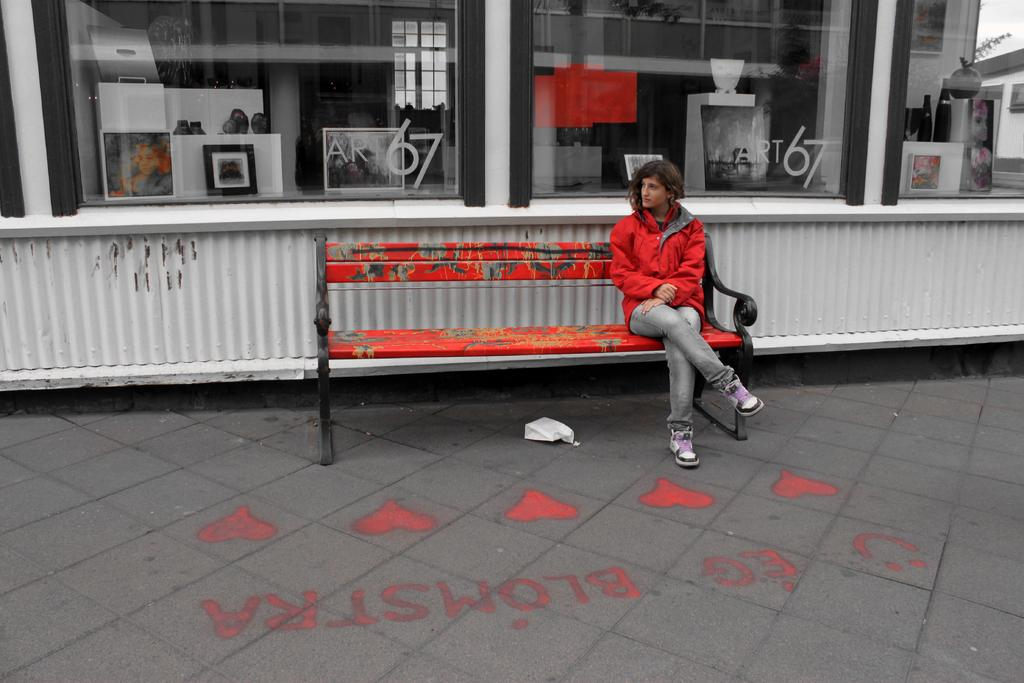Where was the image taken? The image was taken on a street. What can be seen in the center of the image? There is a bench in the center of the image. Who is sitting on the bench? A lady is sitting on the bench. What can be seen in the background of the image? There is a building in the background of the image. What type of voice can be heard coming from the lady's toes in the image? There is no indication in the image that the lady's toes are producing any voice, as the image is a still photograph. 